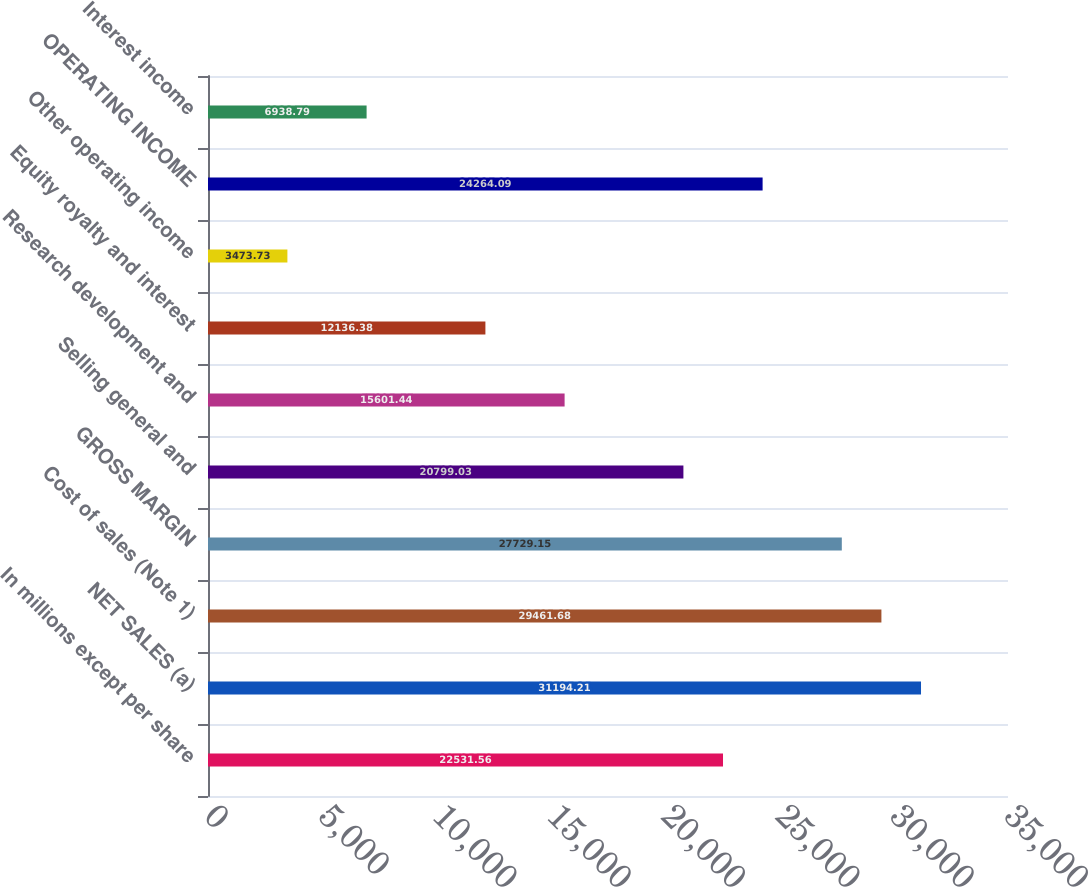Convert chart. <chart><loc_0><loc_0><loc_500><loc_500><bar_chart><fcel>In millions except per share<fcel>NET SALES (a)<fcel>Cost of sales (Note 1)<fcel>GROSS MARGIN<fcel>Selling general and<fcel>Research development and<fcel>Equity royalty and interest<fcel>Other operating income<fcel>OPERATING INCOME<fcel>Interest income<nl><fcel>22531.6<fcel>31194.2<fcel>29461.7<fcel>27729.2<fcel>20799<fcel>15601.4<fcel>12136.4<fcel>3473.73<fcel>24264.1<fcel>6938.79<nl></chart> 